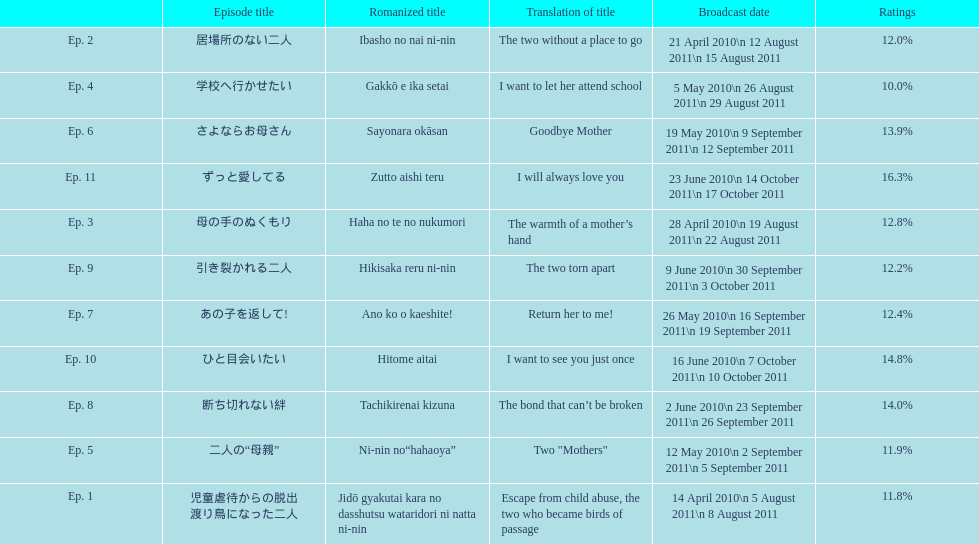How many episodes are listed? 11. Can you parse all the data within this table? {'header': ['', 'Episode title', 'Romanized title', 'Translation of title', 'Broadcast date', 'Ratings'], 'rows': [['Ep. 2', '居場所のない二人', 'Ibasho no nai ni-nin', 'The two without a place to go', '21 April 2010\\n 12 August 2011\\n 15 August 2011', '12.0%'], ['Ep. 4', '学校へ行かせたい', 'Gakkō e ika setai', 'I want to let her attend school', '5 May 2010\\n 26 August 2011\\n 29 August 2011', '10.0%'], ['Ep. 6', 'さよならお母さん', 'Sayonara okāsan', 'Goodbye Mother', '19 May 2010\\n 9 September 2011\\n 12 September 2011', '13.9%'], ['Ep. 11', 'ずっと愛してる', 'Zutto aishi teru', 'I will always love you', '23 June 2010\\n 14 October 2011\\n 17 October 2011', '16.3%'], ['Ep. 3', '母の手のぬくもり', 'Haha no te no nukumori', 'The warmth of a mother’s hand', '28 April 2010\\n 19 August 2011\\n 22 August 2011', '12.8%'], ['Ep. 9', '引き裂かれる二人', 'Hikisaka reru ni-nin', 'The two torn apart', '9 June 2010\\n 30 September 2011\\n 3 October 2011', '12.2%'], ['Ep. 7', 'あの子を返して!', 'Ano ko o kaeshite!', 'Return her to me!', '26 May 2010\\n 16 September 2011\\n 19 September 2011', '12.4%'], ['Ep. 10', 'ひと目会いたい', 'Hitome aitai', 'I want to see you just once', '16 June 2010\\n 7 October 2011\\n 10 October 2011', '14.8%'], ['Ep. 8', '断ち切れない絆', 'Tachikirenai kizuna', 'The bond that can’t be broken', '2 June 2010\\n 23 September 2011\\n 26 September 2011', '14.0%'], ['Ep. 5', '二人の“母親”', 'Ni-nin no“hahaoya”', 'Two "Mothers"', '12 May 2010\\n 2 September 2011\\n 5 September 2011', '11.9%'], ['Ep. 1', '児童虐待からの脱出 渡り鳥になった二人', 'Jidō gyakutai kara no dasshutsu wataridori ni natta ni-nin', 'Escape from child abuse, the two who became birds of passage', '14 April 2010\\n 5 August 2011\\n 8 August 2011', '11.8%']]} 